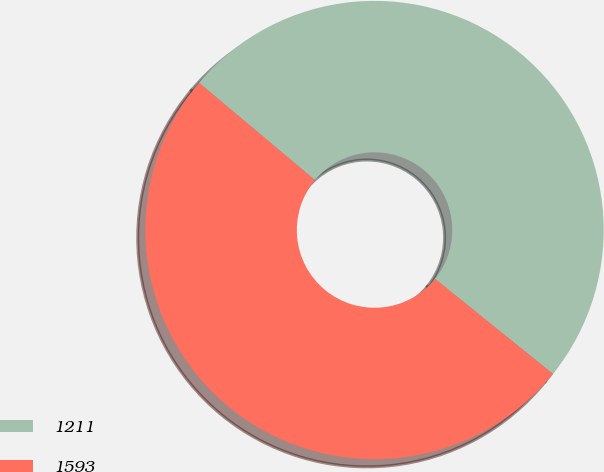<chart> <loc_0><loc_0><loc_500><loc_500><pie_chart><fcel>1211<fcel>1593<nl><fcel>49.69%<fcel>50.31%<nl></chart> 